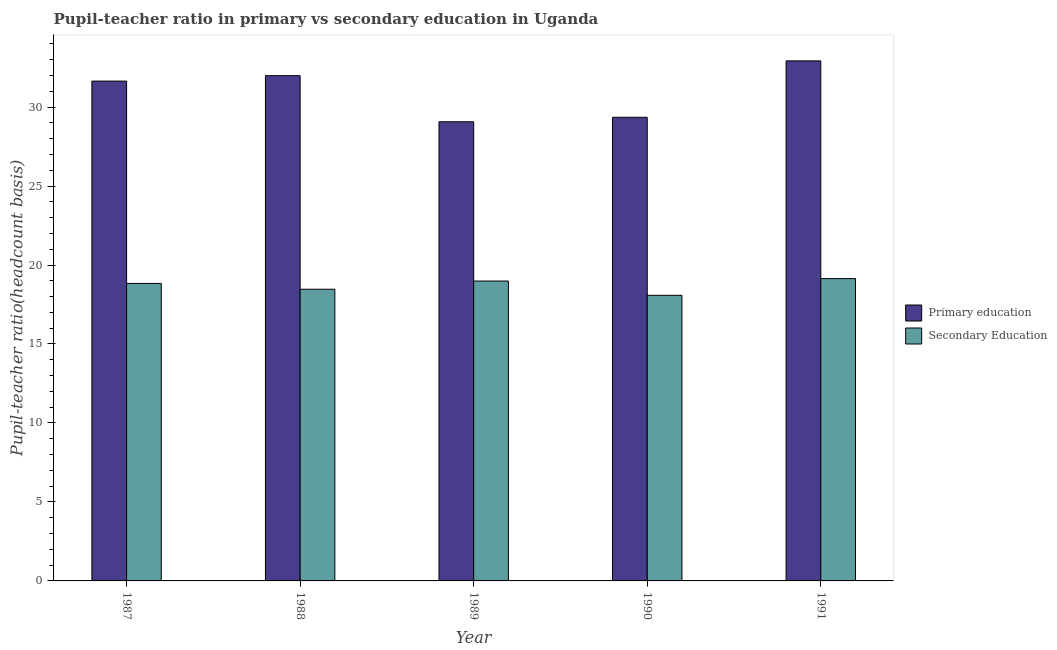How many groups of bars are there?
Your answer should be very brief. 5. Are the number of bars per tick equal to the number of legend labels?
Your response must be concise. Yes. What is the pupil-teacher ratio in primary education in 1987?
Give a very brief answer. 31.64. Across all years, what is the maximum pupil-teacher ratio in primary education?
Your response must be concise. 32.92. Across all years, what is the minimum pupil teacher ratio on secondary education?
Your answer should be very brief. 18.08. What is the total pupil teacher ratio on secondary education in the graph?
Give a very brief answer. 93.51. What is the difference between the pupil teacher ratio on secondary education in 1989 and that in 1990?
Offer a very short reply. 0.9. What is the difference between the pupil teacher ratio on secondary education in 1988 and the pupil-teacher ratio in primary education in 1987?
Provide a succinct answer. -0.37. What is the average pupil-teacher ratio in primary education per year?
Offer a terse response. 30.99. In the year 1991, what is the difference between the pupil teacher ratio on secondary education and pupil-teacher ratio in primary education?
Ensure brevity in your answer.  0. What is the ratio of the pupil-teacher ratio in primary education in 1987 to that in 1988?
Your answer should be compact. 0.99. Is the pupil teacher ratio on secondary education in 1989 less than that in 1990?
Make the answer very short. No. What is the difference between the highest and the second highest pupil teacher ratio on secondary education?
Ensure brevity in your answer.  0.15. What is the difference between the highest and the lowest pupil-teacher ratio in primary education?
Offer a very short reply. 3.86. In how many years, is the pupil teacher ratio on secondary education greater than the average pupil teacher ratio on secondary education taken over all years?
Ensure brevity in your answer.  3. Is the sum of the pupil-teacher ratio in primary education in 1990 and 1991 greater than the maximum pupil teacher ratio on secondary education across all years?
Offer a terse response. Yes. What does the 2nd bar from the left in 1988 represents?
Your answer should be very brief. Secondary Education. What does the 1st bar from the right in 1991 represents?
Ensure brevity in your answer.  Secondary Education. How many bars are there?
Your response must be concise. 10. Are the values on the major ticks of Y-axis written in scientific E-notation?
Your response must be concise. No. Does the graph contain any zero values?
Provide a short and direct response. No. How many legend labels are there?
Offer a terse response. 2. How are the legend labels stacked?
Make the answer very short. Vertical. What is the title of the graph?
Make the answer very short. Pupil-teacher ratio in primary vs secondary education in Uganda. What is the label or title of the Y-axis?
Offer a very short reply. Pupil-teacher ratio(headcount basis). What is the Pupil-teacher ratio(headcount basis) of Primary education in 1987?
Give a very brief answer. 31.64. What is the Pupil-teacher ratio(headcount basis) of Secondary Education in 1987?
Give a very brief answer. 18.83. What is the Pupil-teacher ratio(headcount basis) of Primary education in 1988?
Offer a terse response. 31.99. What is the Pupil-teacher ratio(headcount basis) in Secondary Education in 1988?
Ensure brevity in your answer.  18.47. What is the Pupil-teacher ratio(headcount basis) of Primary education in 1989?
Your answer should be compact. 29.07. What is the Pupil-teacher ratio(headcount basis) of Secondary Education in 1989?
Your response must be concise. 18.98. What is the Pupil-teacher ratio(headcount basis) of Primary education in 1990?
Your answer should be very brief. 29.35. What is the Pupil-teacher ratio(headcount basis) in Secondary Education in 1990?
Offer a terse response. 18.08. What is the Pupil-teacher ratio(headcount basis) of Primary education in 1991?
Provide a succinct answer. 32.92. What is the Pupil-teacher ratio(headcount basis) in Secondary Education in 1991?
Give a very brief answer. 19.14. Across all years, what is the maximum Pupil-teacher ratio(headcount basis) in Primary education?
Provide a succinct answer. 32.92. Across all years, what is the maximum Pupil-teacher ratio(headcount basis) in Secondary Education?
Provide a short and direct response. 19.14. Across all years, what is the minimum Pupil-teacher ratio(headcount basis) of Primary education?
Provide a succinct answer. 29.07. Across all years, what is the minimum Pupil-teacher ratio(headcount basis) of Secondary Education?
Give a very brief answer. 18.08. What is the total Pupil-teacher ratio(headcount basis) of Primary education in the graph?
Your answer should be compact. 154.97. What is the total Pupil-teacher ratio(headcount basis) of Secondary Education in the graph?
Offer a terse response. 93.51. What is the difference between the Pupil-teacher ratio(headcount basis) in Primary education in 1987 and that in 1988?
Ensure brevity in your answer.  -0.34. What is the difference between the Pupil-teacher ratio(headcount basis) in Secondary Education in 1987 and that in 1988?
Make the answer very short. 0.37. What is the difference between the Pupil-teacher ratio(headcount basis) in Primary education in 1987 and that in 1989?
Ensure brevity in your answer.  2.58. What is the difference between the Pupil-teacher ratio(headcount basis) of Primary education in 1987 and that in 1990?
Give a very brief answer. 2.29. What is the difference between the Pupil-teacher ratio(headcount basis) in Secondary Education in 1987 and that in 1990?
Your response must be concise. 0.75. What is the difference between the Pupil-teacher ratio(headcount basis) of Primary education in 1987 and that in 1991?
Provide a succinct answer. -1.28. What is the difference between the Pupil-teacher ratio(headcount basis) in Secondary Education in 1987 and that in 1991?
Offer a terse response. -0.3. What is the difference between the Pupil-teacher ratio(headcount basis) of Primary education in 1988 and that in 1989?
Offer a very short reply. 2.92. What is the difference between the Pupil-teacher ratio(headcount basis) of Secondary Education in 1988 and that in 1989?
Your response must be concise. -0.52. What is the difference between the Pupil-teacher ratio(headcount basis) of Primary education in 1988 and that in 1990?
Make the answer very short. 2.63. What is the difference between the Pupil-teacher ratio(headcount basis) in Secondary Education in 1988 and that in 1990?
Provide a short and direct response. 0.39. What is the difference between the Pupil-teacher ratio(headcount basis) in Primary education in 1988 and that in 1991?
Keep it short and to the point. -0.94. What is the difference between the Pupil-teacher ratio(headcount basis) in Secondary Education in 1988 and that in 1991?
Your answer should be compact. -0.67. What is the difference between the Pupil-teacher ratio(headcount basis) of Primary education in 1989 and that in 1990?
Keep it short and to the point. -0.28. What is the difference between the Pupil-teacher ratio(headcount basis) in Secondary Education in 1989 and that in 1990?
Offer a very short reply. 0.9. What is the difference between the Pupil-teacher ratio(headcount basis) in Primary education in 1989 and that in 1991?
Provide a short and direct response. -3.86. What is the difference between the Pupil-teacher ratio(headcount basis) in Secondary Education in 1989 and that in 1991?
Provide a succinct answer. -0.15. What is the difference between the Pupil-teacher ratio(headcount basis) of Primary education in 1990 and that in 1991?
Your answer should be compact. -3.57. What is the difference between the Pupil-teacher ratio(headcount basis) of Secondary Education in 1990 and that in 1991?
Make the answer very short. -1.06. What is the difference between the Pupil-teacher ratio(headcount basis) of Primary education in 1987 and the Pupil-teacher ratio(headcount basis) of Secondary Education in 1988?
Ensure brevity in your answer.  13.18. What is the difference between the Pupil-teacher ratio(headcount basis) of Primary education in 1987 and the Pupil-teacher ratio(headcount basis) of Secondary Education in 1989?
Provide a succinct answer. 12.66. What is the difference between the Pupil-teacher ratio(headcount basis) in Primary education in 1987 and the Pupil-teacher ratio(headcount basis) in Secondary Education in 1990?
Your answer should be compact. 13.56. What is the difference between the Pupil-teacher ratio(headcount basis) of Primary education in 1987 and the Pupil-teacher ratio(headcount basis) of Secondary Education in 1991?
Your response must be concise. 12.5. What is the difference between the Pupil-teacher ratio(headcount basis) of Primary education in 1988 and the Pupil-teacher ratio(headcount basis) of Secondary Education in 1989?
Make the answer very short. 13. What is the difference between the Pupil-teacher ratio(headcount basis) in Primary education in 1988 and the Pupil-teacher ratio(headcount basis) in Secondary Education in 1990?
Your response must be concise. 13.91. What is the difference between the Pupil-teacher ratio(headcount basis) of Primary education in 1988 and the Pupil-teacher ratio(headcount basis) of Secondary Education in 1991?
Your answer should be very brief. 12.85. What is the difference between the Pupil-teacher ratio(headcount basis) of Primary education in 1989 and the Pupil-teacher ratio(headcount basis) of Secondary Education in 1990?
Provide a short and direct response. 10.99. What is the difference between the Pupil-teacher ratio(headcount basis) in Primary education in 1989 and the Pupil-teacher ratio(headcount basis) in Secondary Education in 1991?
Make the answer very short. 9.93. What is the difference between the Pupil-teacher ratio(headcount basis) in Primary education in 1990 and the Pupil-teacher ratio(headcount basis) in Secondary Education in 1991?
Provide a short and direct response. 10.21. What is the average Pupil-teacher ratio(headcount basis) in Primary education per year?
Keep it short and to the point. 30.99. What is the average Pupil-teacher ratio(headcount basis) in Secondary Education per year?
Provide a succinct answer. 18.7. In the year 1987, what is the difference between the Pupil-teacher ratio(headcount basis) of Primary education and Pupil-teacher ratio(headcount basis) of Secondary Education?
Ensure brevity in your answer.  12.81. In the year 1988, what is the difference between the Pupil-teacher ratio(headcount basis) in Primary education and Pupil-teacher ratio(headcount basis) in Secondary Education?
Provide a succinct answer. 13.52. In the year 1989, what is the difference between the Pupil-teacher ratio(headcount basis) of Primary education and Pupil-teacher ratio(headcount basis) of Secondary Education?
Keep it short and to the point. 10.08. In the year 1990, what is the difference between the Pupil-teacher ratio(headcount basis) of Primary education and Pupil-teacher ratio(headcount basis) of Secondary Education?
Offer a very short reply. 11.27. In the year 1991, what is the difference between the Pupil-teacher ratio(headcount basis) of Primary education and Pupil-teacher ratio(headcount basis) of Secondary Education?
Ensure brevity in your answer.  13.78. What is the ratio of the Pupil-teacher ratio(headcount basis) in Primary education in 1987 to that in 1988?
Offer a terse response. 0.99. What is the ratio of the Pupil-teacher ratio(headcount basis) in Primary education in 1987 to that in 1989?
Make the answer very short. 1.09. What is the ratio of the Pupil-teacher ratio(headcount basis) of Secondary Education in 1987 to that in 1989?
Make the answer very short. 0.99. What is the ratio of the Pupil-teacher ratio(headcount basis) in Primary education in 1987 to that in 1990?
Provide a short and direct response. 1.08. What is the ratio of the Pupil-teacher ratio(headcount basis) of Secondary Education in 1987 to that in 1990?
Offer a very short reply. 1.04. What is the ratio of the Pupil-teacher ratio(headcount basis) in Primary education in 1987 to that in 1991?
Your answer should be very brief. 0.96. What is the ratio of the Pupil-teacher ratio(headcount basis) of Secondary Education in 1987 to that in 1991?
Keep it short and to the point. 0.98. What is the ratio of the Pupil-teacher ratio(headcount basis) in Primary education in 1988 to that in 1989?
Your answer should be compact. 1.1. What is the ratio of the Pupil-teacher ratio(headcount basis) of Secondary Education in 1988 to that in 1989?
Ensure brevity in your answer.  0.97. What is the ratio of the Pupil-teacher ratio(headcount basis) in Primary education in 1988 to that in 1990?
Your answer should be very brief. 1.09. What is the ratio of the Pupil-teacher ratio(headcount basis) of Secondary Education in 1988 to that in 1990?
Provide a short and direct response. 1.02. What is the ratio of the Pupil-teacher ratio(headcount basis) of Primary education in 1988 to that in 1991?
Offer a very short reply. 0.97. What is the ratio of the Pupil-teacher ratio(headcount basis) of Secondary Education in 1988 to that in 1991?
Provide a short and direct response. 0.96. What is the ratio of the Pupil-teacher ratio(headcount basis) of Primary education in 1989 to that in 1990?
Provide a short and direct response. 0.99. What is the ratio of the Pupil-teacher ratio(headcount basis) in Secondary Education in 1989 to that in 1990?
Ensure brevity in your answer.  1.05. What is the ratio of the Pupil-teacher ratio(headcount basis) in Primary education in 1989 to that in 1991?
Ensure brevity in your answer.  0.88. What is the ratio of the Pupil-teacher ratio(headcount basis) of Secondary Education in 1989 to that in 1991?
Give a very brief answer. 0.99. What is the ratio of the Pupil-teacher ratio(headcount basis) of Primary education in 1990 to that in 1991?
Offer a very short reply. 0.89. What is the ratio of the Pupil-teacher ratio(headcount basis) in Secondary Education in 1990 to that in 1991?
Offer a terse response. 0.94. What is the difference between the highest and the second highest Pupil-teacher ratio(headcount basis) of Primary education?
Offer a terse response. 0.94. What is the difference between the highest and the second highest Pupil-teacher ratio(headcount basis) in Secondary Education?
Offer a very short reply. 0.15. What is the difference between the highest and the lowest Pupil-teacher ratio(headcount basis) of Primary education?
Provide a short and direct response. 3.86. What is the difference between the highest and the lowest Pupil-teacher ratio(headcount basis) in Secondary Education?
Your answer should be compact. 1.06. 